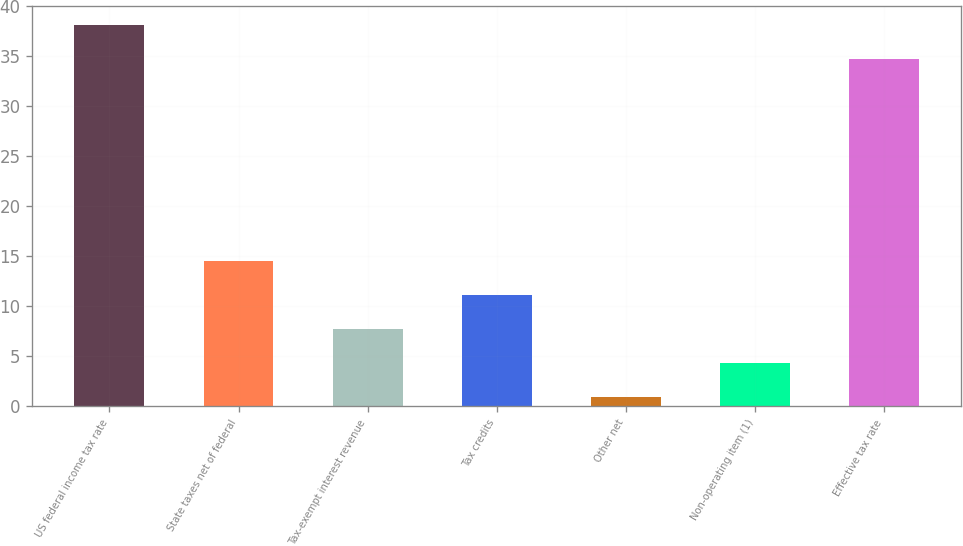Convert chart to OTSL. <chart><loc_0><loc_0><loc_500><loc_500><bar_chart><fcel>US federal income tax rate<fcel>State taxes net of federal<fcel>Tax-exempt interest revenue<fcel>Tax credits<fcel>Other net<fcel>Non-operating item (1)<fcel>Effective tax rate<nl><fcel>38.11<fcel>14.54<fcel>7.72<fcel>11.13<fcel>0.9<fcel>4.31<fcel>34.7<nl></chart> 